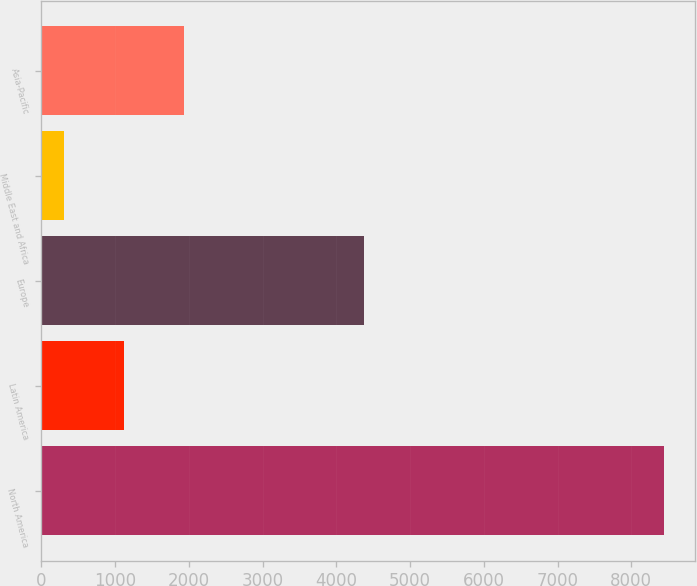<chart> <loc_0><loc_0><loc_500><loc_500><bar_chart><fcel>North America<fcel>Latin America<fcel>Europe<fcel>Middle East and Africa<fcel>Asia-Pacific<nl><fcel>8442.5<fcel>1118.21<fcel>4375.4<fcel>304.4<fcel>1932.02<nl></chart> 